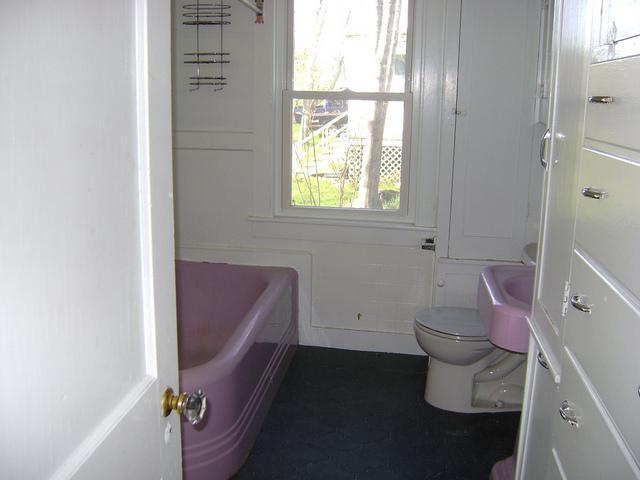How many toilets can you see?
Give a very brief answer. 1. 